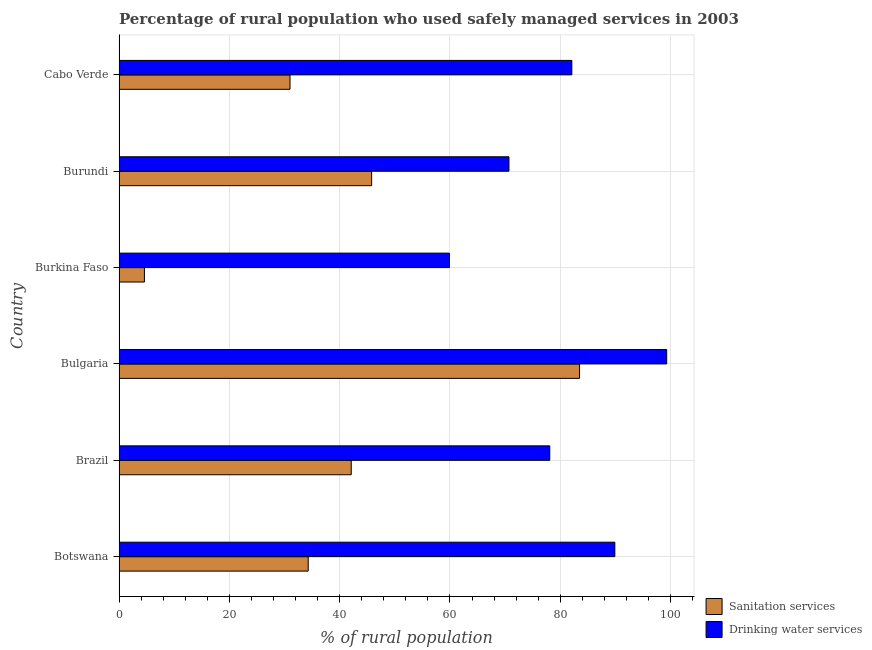Are the number of bars per tick equal to the number of legend labels?
Give a very brief answer. Yes. Are the number of bars on each tick of the Y-axis equal?
Your response must be concise. Yes. What is the percentage of rural population who used drinking water services in Burundi?
Keep it short and to the point. 70.7. Across all countries, what is the maximum percentage of rural population who used sanitation services?
Make the answer very short. 83.5. In which country was the percentage of rural population who used sanitation services minimum?
Provide a succinct answer. Burkina Faso. What is the total percentage of rural population who used drinking water services in the graph?
Offer a terse response. 480. What is the difference between the percentage of rural population who used sanitation services in Bulgaria and that in Burkina Faso?
Make the answer very short. 78.9. What is the difference between the percentage of rural population who used drinking water services in Burundi and the percentage of rural population who used sanitation services in Brazil?
Make the answer very short. 28.6. What is the average percentage of rural population who used drinking water services per country?
Make the answer very short. 80. What is the difference between the percentage of rural population who used drinking water services and percentage of rural population who used sanitation services in Burkina Faso?
Ensure brevity in your answer.  55.3. In how many countries, is the percentage of rural population who used drinking water services greater than 24 %?
Your answer should be compact. 6. What is the ratio of the percentage of rural population who used drinking water services in Burundi to that in Cabo Verde?
Offer a terse response. 0.86. What is the difference between the highest and the second highest percentage of rural population who used sanitation services?
Your answer should be very brief. 37.7. What is the difference between the highest and the lowest percentage of rural population who used sanitation services?
Offer a terse response. 78.9. In how many countries, is the percentage of rural population who used sanitation services greater than the average percentage of rural population who used sanitation services taken over all countries?
Offer a very short reply. 3. What does the 1st bar from the top in Burundi represents?
Offer a very short reply. Drinking water services. What does the 2nd bar from the bottom in Burundi represents?
Ensure brevity in your answer.  Drinking water services. Are all the bars in the graph horizontal?
Provide a short and direct response. Yes. How many countries are there in the graph?
Make the answer very short. 6. Are the values on the major ticks of X-axis written in scientific E-notation?
Your answer should be compact. No. Does the graph contain any zero values?
Your answer should be very brief. No. Does the graph contain grids?
Give a very brief answer. Yes. How many legend labels are there?
Your answer should be compact. 2. How are the legend labels stacked?
Provide a succinct answer. Vertical. What is the title of the graph?
Your response must be concise. Percentage of rural population who used safely managed services in 2003. Does "Private creditors" appear as one of the legend labels in the graph?
Provide a short and direct response. No. What is the label or title of the X-axis?
Provide a succinct answer. % of rural population. What is the % of rural population of Sanitation services in Botswana?
Keep it short and to the point. 34.3. What is the % of rural population of Drinking water services in Botswana?
Ensure brevity in your answer.  89.9. What is the % of rural population of Sanitation services in Brazil?
Your answer should be very brief. 42.1. What is the % of rural population of Drinking water services in Brazil?
Your answer should be compact. 78.1. What is the % of rural population of Sanitation services in Bulgaria?
Keep it short and to the point. 83.5. What is the % of rural population of Drinking water services in Bulgaria?
Provide a short and direct response. 99.3. What is the % of rural population in Drinking water services in Burkina Faso?
Your answer should be very brief. 59.9. What is the % of rural population in Sanitation services in Burundi?
Your answer should be very brief. 45.8. What is the % of rural population in Drinking water services in Burundi?
Offer a terse response. 70.7. What is the % of rural population in Drinking water services in Cabo Verde?
Provide a short and direct response. 82.1. Across all countries, what is the maximum % of rural population of Sanitation services?
Provide a succinct answer. 83.5. Across all countries, what is the maximum % of rural population in Drinking water services?
Provide a succinct answer. 99.3. Across all countries, what is the minimum % of rural population in Sanitation services?
Ensure brevity in your answer.  4.6. Across all countries, what is the minimum % of rural population in Drinking water services?
Your answer should be very brief. 59.9. What is the total % of rural population in Sanitation services in the graph?
Give a very brief answer. 241.3. What is the total % of rural population in Drinking water services in the graph?
Offer a terse response. 480. What is the difference between the % of rural population in Sanitation services in Botswana and that in Brazil?
Offer a very short reply. -7.8. What is the difference between the % of rural population in Sanitation services in Botswana and that in Bulgaria?
Keep it short and to the point. -49.2. What is the difference between the % of rural population of Drinking water services in Botswana and that in Bulgaria?
Provide a short and direct response. -9.4. What is the difference between the % of rural population in Sanitation services in Botswana and that in Burkina Faso?
Provide a short and direct response. 29.7. What is the difference between the % of rural population in Drinking water services in Botswana and that in Burkina Faso?
Give a very brief answer. 30. What is the difference between the % of rural population of Sanitation services in Botswana and that in Burundi?
Your answer should be very brief. -11.5. What is the difference between the % of rural population of Drinking water services in Botswana and that in Burundi?
Ensure brevity in your answer.  19.2. What is the difference between the % of rural population of Sanitation services in Botswana and that in Cabo Verde?
Your answer should be compact. 3.3. What is the difference between the % of rural population of Sanitation services in Brazil and that in Bulgaria?
Your answer should be very brief. -41.4. What is the difference between the % of rural population in Drinking water services in Brazil and that in Bulgaria?
Provide a short and direct response. -21.2. What is the difference between the % of rural population in Sanitation services in Brazil and that in Burkina Faso?
Keep it short and to the point. 37.5. What is the difference between the % of rural population of Sanitation services in Brazil and that in Burundi?
Make the answer very short. -3.7. What is the difference between the % of rural population of Drinking water services in Brazil and that in Cabo Verde?
Offer a very short reply. -4. What is the difference between the % of rural population in Sanitation services in Bulgaria and that in Burkina Faso?
Make the answer very short. 78.9. What is the difference between the % of rural population in Drinking water services in Bulgaria and that in Burkina Faso?
Keep it short and to the point. 39.4. What is the difference between the % of rural population in Sanitation services in Bulgaria and that in Burundi?
Your response must be concise. 37.7. What is the difference between the % of rural population of Drinking water services in Bulgaria and that in Burundi?
Your answer should be very brief. 28.6. What is the difference between the % of rural population of Sanitation services in Bulgaria and that in Cabo Verde?
Offer a very short reply. 52.5. What is the difference between the % of rural population of Drinking water services in Bulgaria and that in Cabo Verde?
Provide a succinct answer. 17.2. What is the difference between the % of rural population of Sanitation services in Burkina Faso and that in Burundi?
Give a very brief answer. -41.2. What is the difference between the % of rural population of Drinking water services in Burkina Faso and that in Burundi?
Make the answer very short. -10.8. What is the difference between the % of rural population in Sanitation services in Burkina Faso and that in Cabo Verde?
Give a very brief answer. -26.4. What is the difference between the % of rural population of Drinking water services in Burkina Faso and that in Cabo Verde?
Your response must be concise. -22.2. What is the difference between the % of rural population in Sanitation services in Burundi and that in Cabo Verde?
Your answer should be very brief. 14.8. What is the difference between the % of rural population of Sanitation services in Botswana and the % of rural population of Drinking water services in Brazil?
Provide a short and direct response. -43.8. What is the difference between the % of rural population of Sanitation services in Botswana and the % of rural population of Drinking water services in Bulgaria?
Ensure brevity in your answer.  -65. What is the difference between the % of rural population in Sanitation services in Botswana and the % of rural population in Drinking water services in Burkina Faso?
Give a very brief answer. -25.6. What is the difference between the % of rural population of Sanitation services in Botswana and the % of rural population of Drinking water services in Burundi?
Your answer should be very brief. -36.4. What is the difference between the % of rural population of Sanitation services in Botswana and the % of rural population of Drinking water services in Cabo Verde?
Provide a short and direct response. -47.8. What is the difference between the % of rural population of Sanitation services in Brazil and the % of rural population of Drinking water services in Bulgaria?
Offer a terse response. -57.2. What is the difference between the % of rural population of Sanitation services in Brazil and the % of rural population of Drinking water services in Burkina Faso?
Keep it short and to the point. -17.8. What is the difference between the % of rural population in Sanitation services in Brazil and the % of rural population in Drinking water services in Burundi?
Your answer should be very brief. -28.6. What is the difference between the % of rural population in Sanitation services in Brazil and the % of rural population in Drinking water services in Cabo Verde?
Your answer should be compact. -40. What is the difference between the % of rural population of Sanitation services in Bulgaria and the % of rural population of Drinking water services in Burkina Faso?
Give a very brief answer. 23.6. What is the difference between the % of rural population in Sanitation services in Bulgaria and the % of rural population in Drinking water services in Burundi?
Offer a terse response. 12.8. What is the difference between the % of rural population of Sanitation services in Burkina Faso and the % of rural population of Drinking water services in Burundi?
Offer a terse response. -66.1. What is the difference between the % of rural population in Sanitation services in Burkina Faso and the % of rural population in Drinking water services in Cabo Verde?
Make the answer very short. -77.5. What is the difference between the % of rural population of Sanitation services in Burundi and the % of rural population of Drinking water services in Cabo Verde?
Make the answer very short. -36.3. What is the average % of rural population of Sanitation services per country?
Make the answer very short. 40.22. What is the difference between the % of rural population of Sanitation services and % of rural population of Drinking water services in Botswana?
Ensure brevity in your answer.  -55.6. What is the difference between the % of rural population in Sanitation services and % of rural population in Drinking water services in Brazil?
Make the answer very short. -36. What is the difference between the % of rural population in Sanitation services and % of rural population in Drinking water services in Bulgaria?
Make the answer very short. -15.8. What is the difference between the % of rural population in Sanitation services and % of rural population in Drinking water services in Burkina Faso?
Offer a terse response. -55.3. What is the difference between the % of rural population of Sanitation services and % of rural population of Drinking water services in Burundi?
Your answer should be compact. -24.9. What is the difference between the % of rural population in Sanitation services and % of rural population in Drinking water services in Cabo Verde?
Make the answer very short. -51.1. What is the ratio of the % of rural population of Sanitation services in Botswana to that in Brazil?
Offer a very short reply. 0.81. What is the ratio of the % of rural population in Drinking water services in Botswana to that in Brazil?
Your answer should be compact. 1.15. What is the ratio of the % of rural population of Sanitation services in Botswana to that in Bulgaria?
Offer a terse response. 0.41. What is the ratio of the % of rural population in Drinking water services in Botswana to that in Bulgaria?
Your answer should be compact. 0.91. What is the ratio of the % of rural population of Sanitation services in Botswana to that in Burkina Faso?
Your answer should be compact. 7.46. What is the ratio of the % of rural population in Drinking water services in Botswana to that in Burkina Faso?
Keep it short and to the point. 1.5. What is the ratio of the % of rural population of Sanitation services in Botswana to that in Burundi?
Provide a short and direct response. 0.75. What is the ratio of the % of rural population in Drinking water services in Botswana to that in Burundi?
Your response must be concise. 1.27. What is the ratio of the % of rural population of Sanitation services in Botswana to that in Cabo Verde?
Keep it short and to the point. 1.11. What is the ratio of the % of rural population in Drinking water services in Botswana to that in Cabo Verde?
Make the answer very short. 1.09. What is the ratio of the % of rural population of Sanitation services in Brazil to that in Bulgaria?
Your answer should be compact. 0.5. What is the ratio of the % of rural population of Drinking water services in Brazil to that in Bulgaria?
Provide a succinct answer. 0.79. What is the ratio of the % of rural population in Sanitation services in Brazil to that in Burkina Faso?
Ensure brevity in your answer.  9.15. What is the ratio of the % of rural population in Drinking water services in Brazil to that in Burkina Faso?
Offer a very short reply. 1.3. What is the ratio of the % of rural population of Sanitation services in Brazil to that in Burundi?
Provide a short and direct response. 0.92. What is the ratio of the % of rural population in Drinking water services in Brazil to that in Burundi?
Provide a short and direct response. 1.1. What is the ratio of the % of rural population of Sanitation services in Brazil to that in Cabo Verde?
Provide a short and direct response. 1.36. What is the ratio of the % of rural population in Drinking water services in Brazil to that in Cabo Verde?
Provide a succinct answer. 0.95. What is the ratio of the % of rural population of Sanitation services in Bulgaria to that in Burkina Faso?
Your response must be concise. 18.15. What is the ratio of the % of rural population of Drinking water services in Bulgaria to that in Burkina Faso?
Provide a succinct answer. 1.66. What is the ratio of the % of rural population in Sanitation services in Bulgaria to that in Burundi?
Ensure brevity in your answer.  1.82. What is the ratio of the % of rural population of Drinking water services in Bulgaria to that in Burundi?
Provide a succinct answer. 1.4. What is the ratio of the % of rural population of Sanitation services in Bulgaria to that in Cabo Verde?
Offer a very short reply. 2.69. What is the ratio of the % of rural population in Drinking water services in Bulgaria to that in Cabo Verde?
Make the answer very short. 1.21. What is the ratio of the % of rural population in Sanitation services in Burkina Faso to that in Burundi?
Ensure brevity in your answer.  0.1. What is the ratio of the % of rural population in Drinking water services in Burkina Faso to that in Burundi?
Ensure brevity in your answer.  0.85. What is the ratio of the % of rural population in Sanitation services in Burkina Faso to that in Cabo Verde?
Keep it short and to the point. 0.15. What is the ratio of the % of rural population in Drinking water services in Burkina Faso to that in Cabo Verde?
Make the answer very short. 0.73. What is the ratio of the % of rural population of Sanitation services in Burundi to that in Cabo Verde?
Give a very brief answer. 1.48. What is the ratio of the % of rural population in Drinking water services in Burundi to that in Cabo Verde?
Your answer should be compact. 0.86. What is the difference between the highest and the second highest % of rural population of Sanitation services?
Offer a terse response. 37.7. What is the difference between the highest and the lowest % of rural population of Sanitation services?
Offer a terse response. 78.9. What is the difference between the highest and the lowest % of rural population of Drinking water services?
Provide a short and direct response. 39.4. 